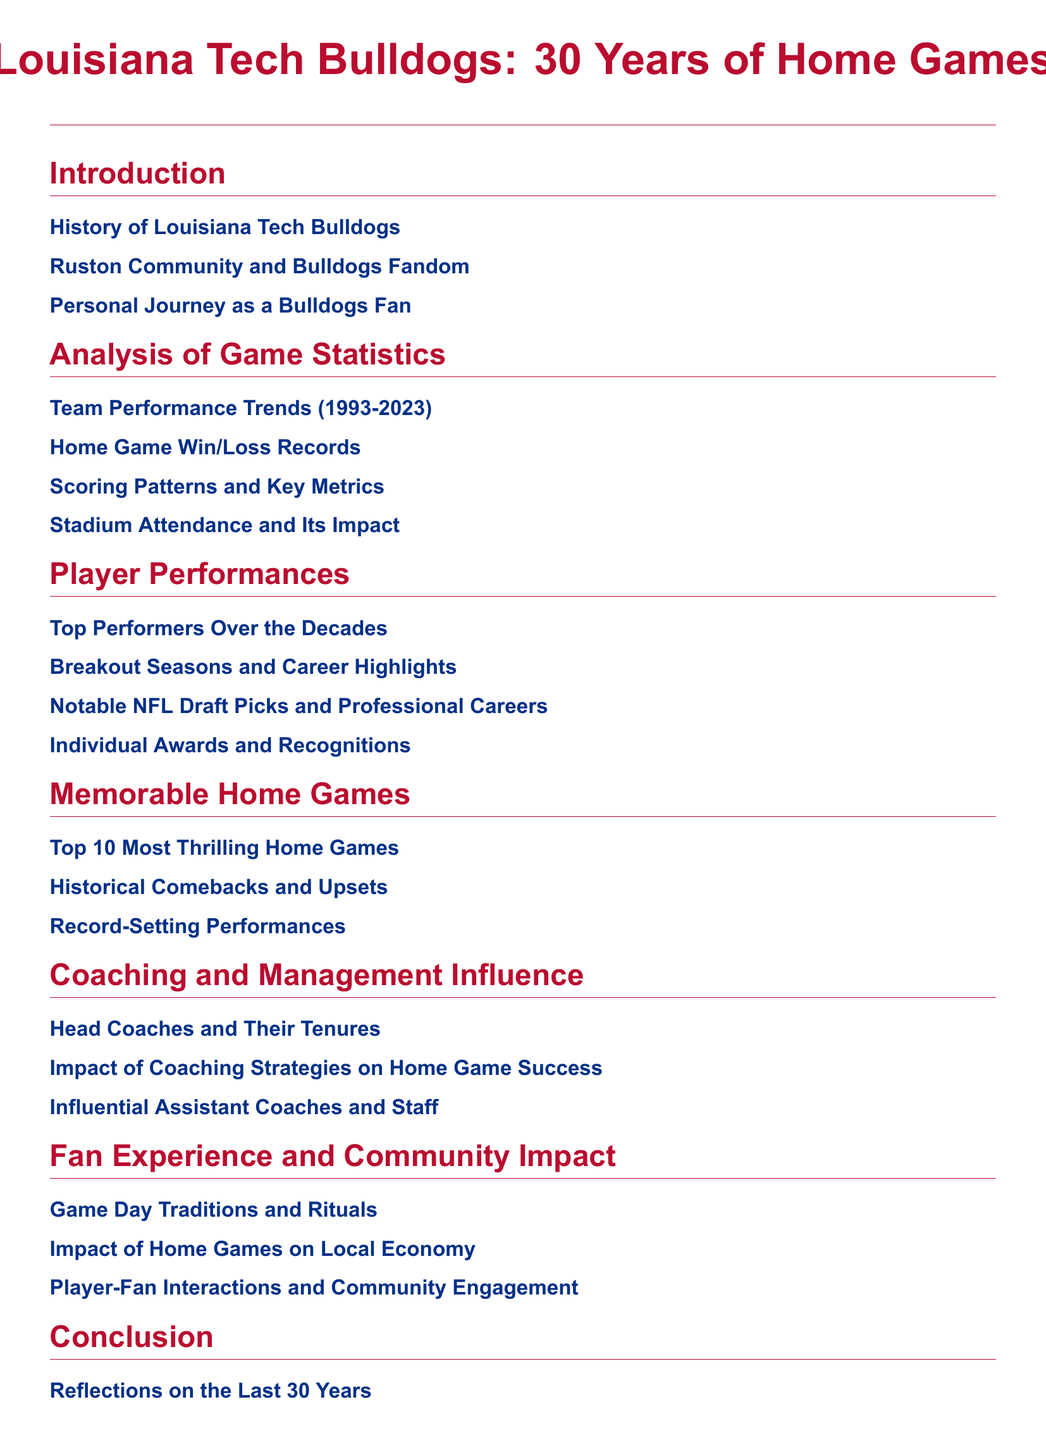What is the title of the document? The title is the main focus of the document, which is centered at the top.
Answer: Louisiana Tech Bulldogs: 30 Years of Home Games How many sections are there in the document? The number of sections can be counted from the table of contents.
Answer: 7 What is the main focus of section 2? This section specifically addresses the game statistics related to the team performance.
Answer: Analysis of Game Statistics Which subsection addresses fans’ interactions? The subsection discusses the community engagement related to games.
Answer: Player-Fan Interactions and Community Engagement What is highlighted in the first subsection of the last section? This subsection reflects personal experiences over the past years.
Answer: Reflections on the Last 30 Years Which coaches' impact is evaluated in section 5? This addresses the leadership and strategies employed by the coaching staff.
Answer: Head Coaches and Their Tenures What is the top focus of the memorable home games section? This section aims to identify the most exciting games in history.
Answer: Top 10 Most Thrilling Home Games 